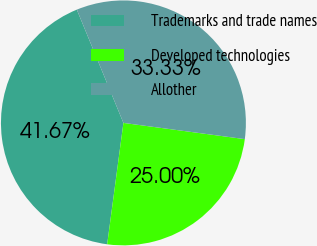Convert chart to OTSL. <chart><loc_0><loc_0><loc_500><loc_500><pie_chart><fcel>Trademarks and trade names<fcel>Developed technologies<fcel>Allother<nl><fcel>41.67%<fcel>25.0%<fcel>33.33%<nl></chart> 